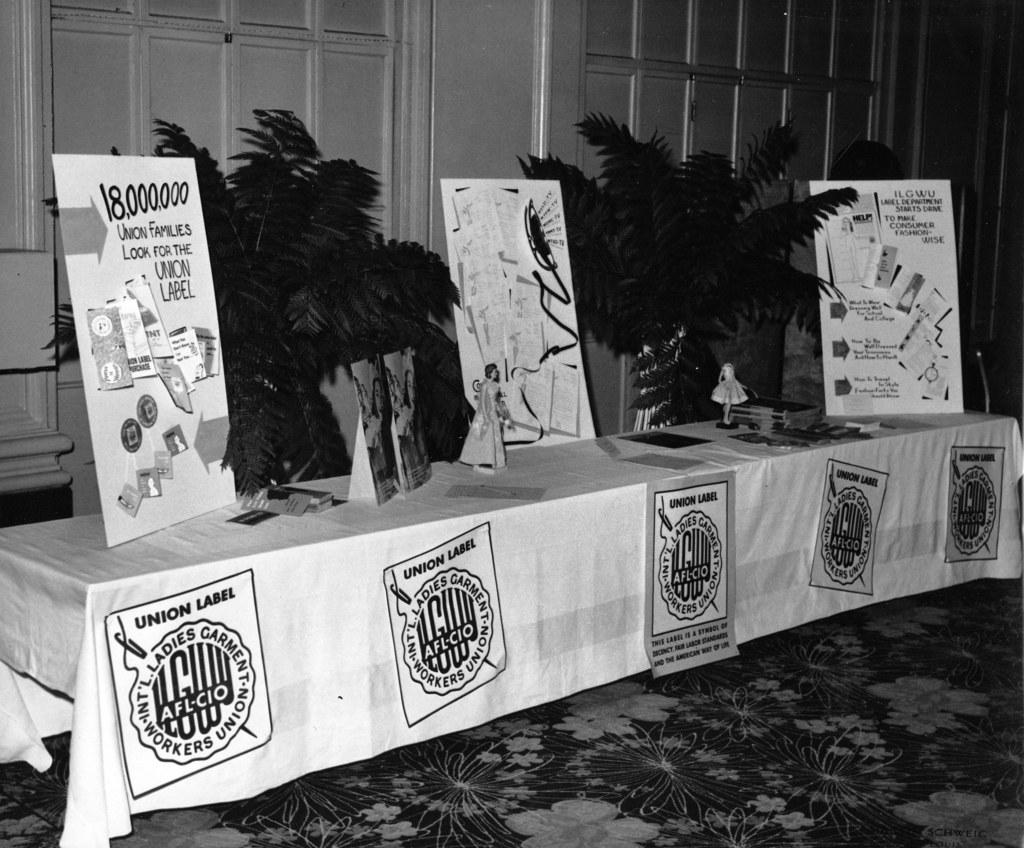<image>
Provide a brief description of the given image. a table with plants and union label on it 